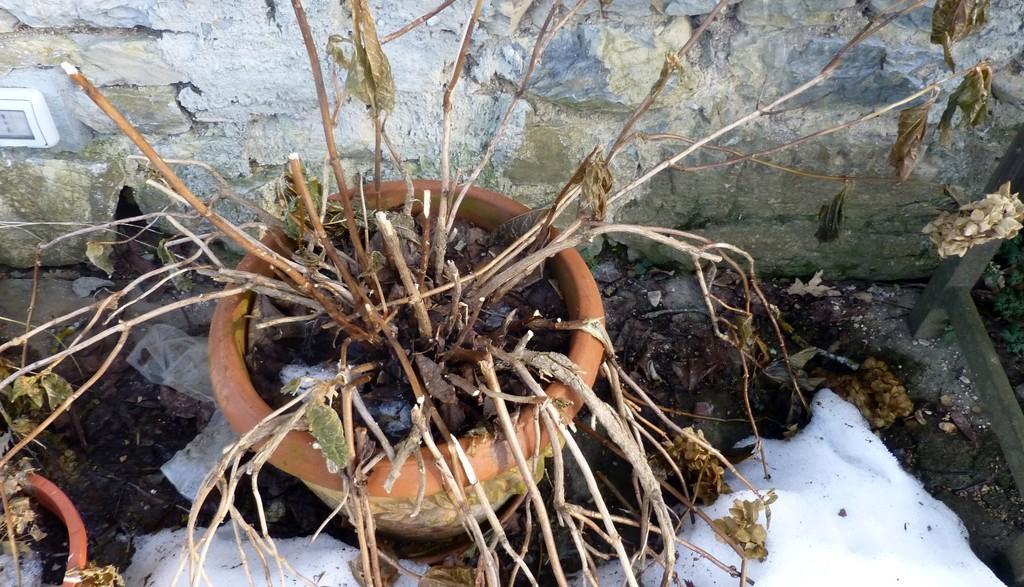Could you give a brief overview of what you see in this image? In this picture I can see a plant in the pot and I can see another plant in the pot on the side and looks like a snow on the ground and I can see a wall in the background. 